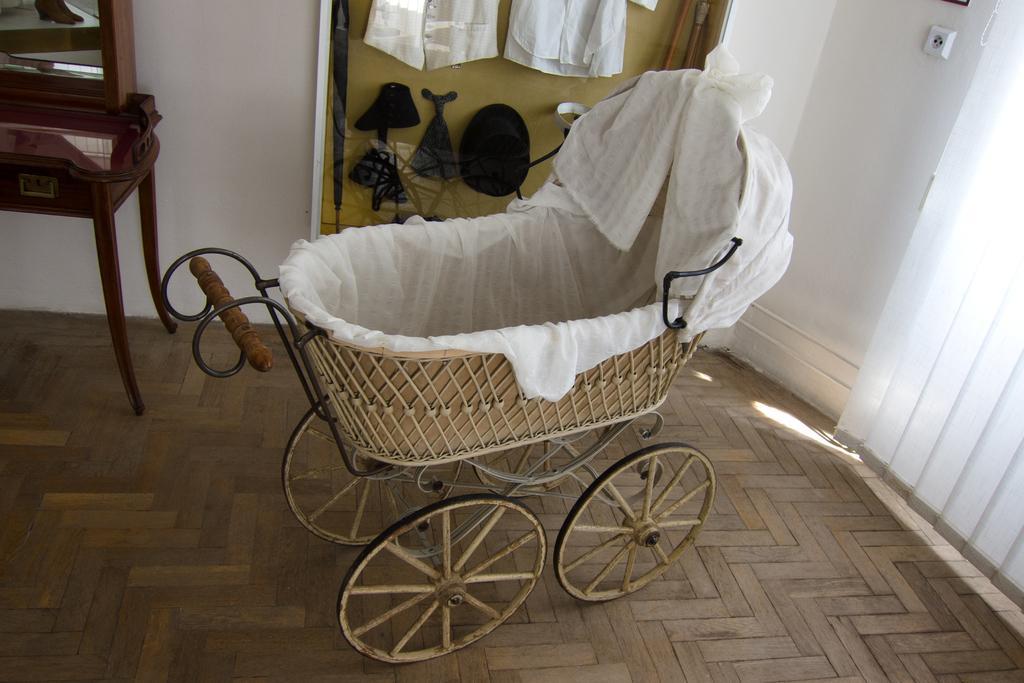How would you summarize this image in a sentence or two? In this image, we can see a baby cart on the floor. Background we can see wall, few things, wooden object and mirror. On the right side of the image, we can see the window shades. 